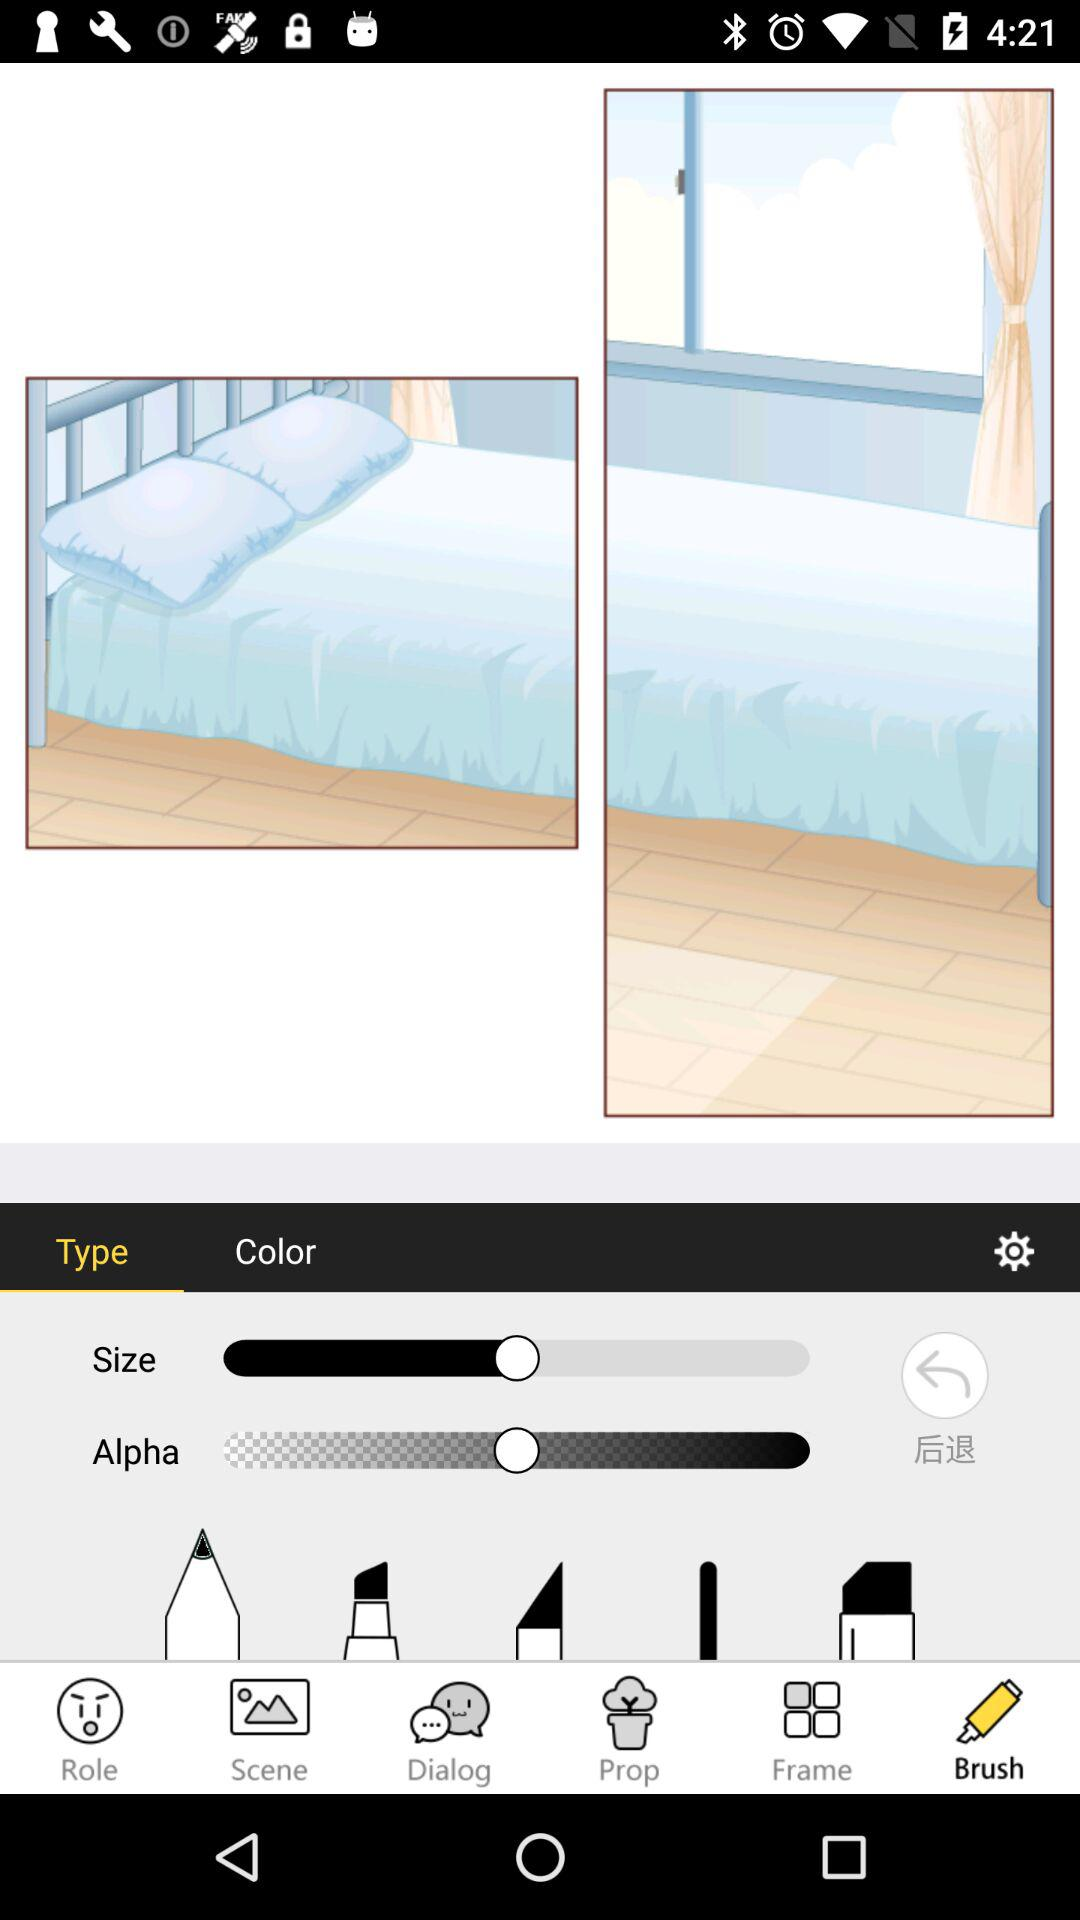Which tab is selected? The selected tabs are "Brush" and "Type". 